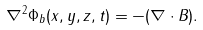Convert formula to latex. <formula><loc_0><loc_0><loc_500><loc_500>\nabla ^ { 2 } \Phi _ { b } ( x , y , z , t ) = - ( \nabla \cdot { B } ) .</formula> 